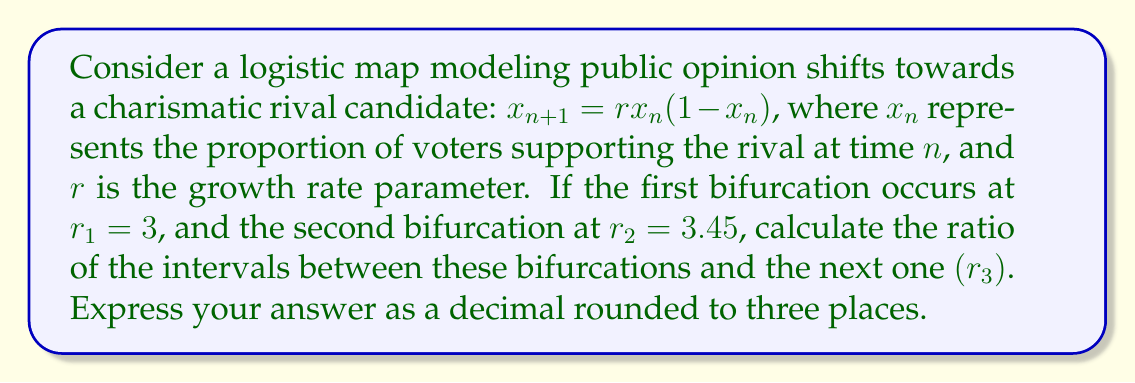Solve this math problem. To solve this problem, we'll follow these steps:

1) In the logistic map, bifurcations occur in a pattern known as period-doubling cascade. The Feigenbaum constant describes the asymptotic ratio of the intervals between successive bifurcations.

2) The Feigenbaum constant $\delta$ is approximately 4.669201...

3) We can use the Feigenbaum constant to estimate the location of the third bifurcation point $r_3$:

   $$\delta \approx \frac{r_2 - r_1}{r_3 - r_2}$$

4) Rearranging this equation:

   $$r_3 \approx r_2 + \frac{r_2 - r_1}{\delta}$$

5) Let's substitute the known values:

   $$r_3 \approx 3.45 + \frac{3.45 - 3}{4.669201}$$

6) Calculating:

   $$r_3 \approx 3.45 + \frac{0.45}{4.669201} \approx 3.45 + 0.0963 \approx 3.5463$$

7) Now we can calculate the ratio of the intervals:

   $$\frac{r_2 - r_1}{r_3 - r_2} = \frac{3.45 - 3}{3.5463 - 3.45} \approx \frac{0.45}{0.0963} \approx 4.672$$

8) Rounding to three decimal places: 4.672

This ratio closely approximates the Feigenbaum constant, demonstrating the universal scaling behavior in the period-doubling cascade, which models the increasingly rapid shifts in public opinion as the system approaches chaos.
Answer: 4.672 